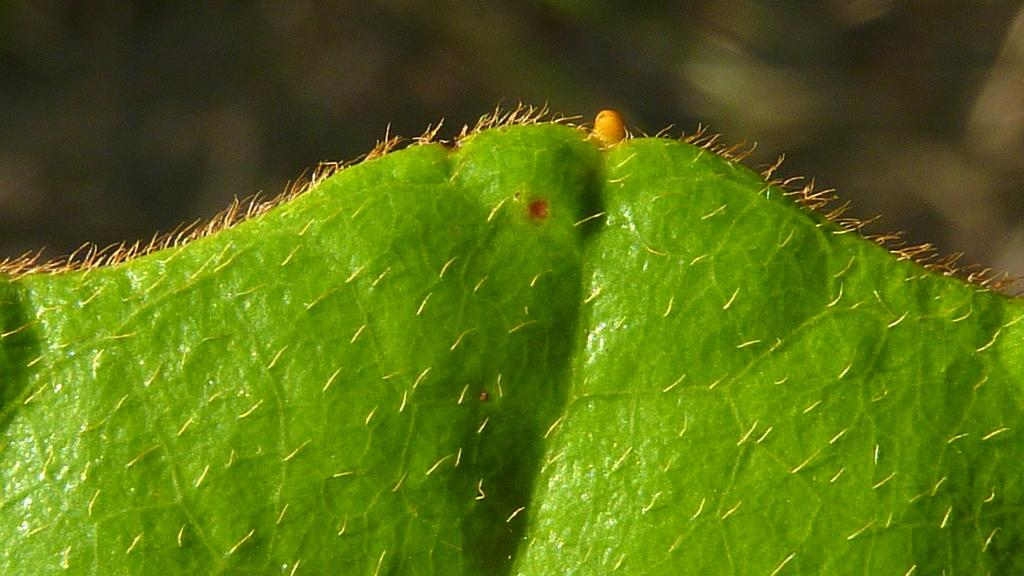What is the color of the leaf in the picture? The leaf in the picture is green. What can be seen on the green leaf? There are yellow color objects on the leaf. What type of music is being played by the oil in the image? There is no oil or music present in the image. 